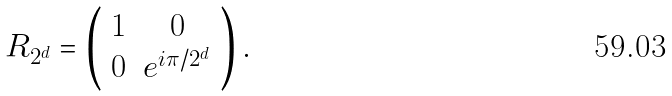Convert formula to latex. <formula><loc_0><loc_0><loc_500><loc_500>R _ { 2 ^ { d } } = \left ( \begin{array} { c c } 1 & 0 \\ 0 & e ^ { i \pi / 2 ^ { d } } \end{array} \right ) .</formula> 